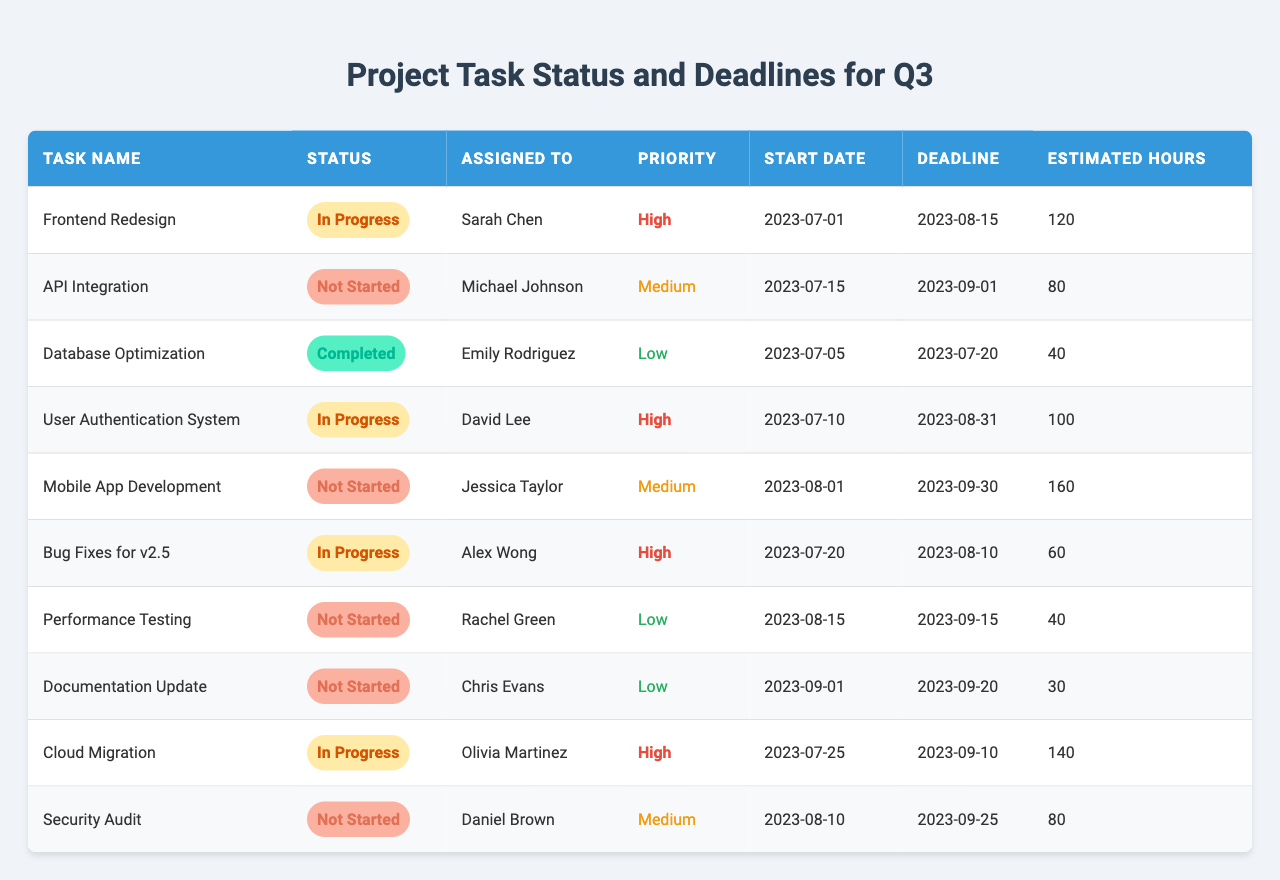What is the status of the "Database Optimization" task? The table indicates that the "Database Optimization" task is "Completed."
Answer: Completed Who is assigned to the "Mobile App Development" task? The "Mobile App Development" task is assigned to Jessica Taylor, as shown in the "Assigned To" column.
Answer: Jessica Taylor What is the deadline for the "Cloud Migration" task? The "Cloud Migration" task has a deadline of "2023-09-10," as indicated in the table under the "Deadline" column.
Answer: 2023-09-10 How many hours are estimated for the "User Authentication System"? The estimated hours for the "User Authentication System" is 100 hours, per the data shown in the "Estimated Hours" column.
Answer: 100 Is there any task with a status of "Not Started"? Yes, the table shows that tasks such as "API Integration," "Mobile App Development," "Performance Testing," and "Security Audit" have a status of "Not Started."
Answer: Yes What is the priority level of the "Bug Fixes for v2.5" task? The priority level of the "Bug Fixes for v2.5" task is "High," as indicated in the "Priority" column of the table.
Answer: High Which task has the earliest start date? The earliest start date is for "Frontend Redesign" which starts on "2023-07-01," making it the task that begins first according to the "Start Date" column.
Answer: Frontend Redesign How many tasks are labeled with "High" priority? There are four tasks with "High" priority as evident from counting the tasks that have "High" in the "Priority" column.
Answer: 4 What is the total estimated hours for tasks that are either "Not Started" or "In Progress"? Adding the estimated hours: API Integration (80) + Mobile App Development (160) + Performance Testing (40) + Security Audit (80) + Frontend Redesign (120) + User Authentication System (100) + Bug Fixes for v2.5 (60) + Cloud Migration (140) equals 780 hours total.
Answer: 780 Which assigned individual has the most tasks in progress? The table shows that Sarah Chen and David Lee each have tasks that are "In Progress," but by counting it shows Sarah Chen with 1 task and David Lee with 1 task. Also, Olivia Martinez and Alex Wong have 1 task each as well. There is no individual with more than 1 task that is "In Progress."
Answer: No one has more than one task 